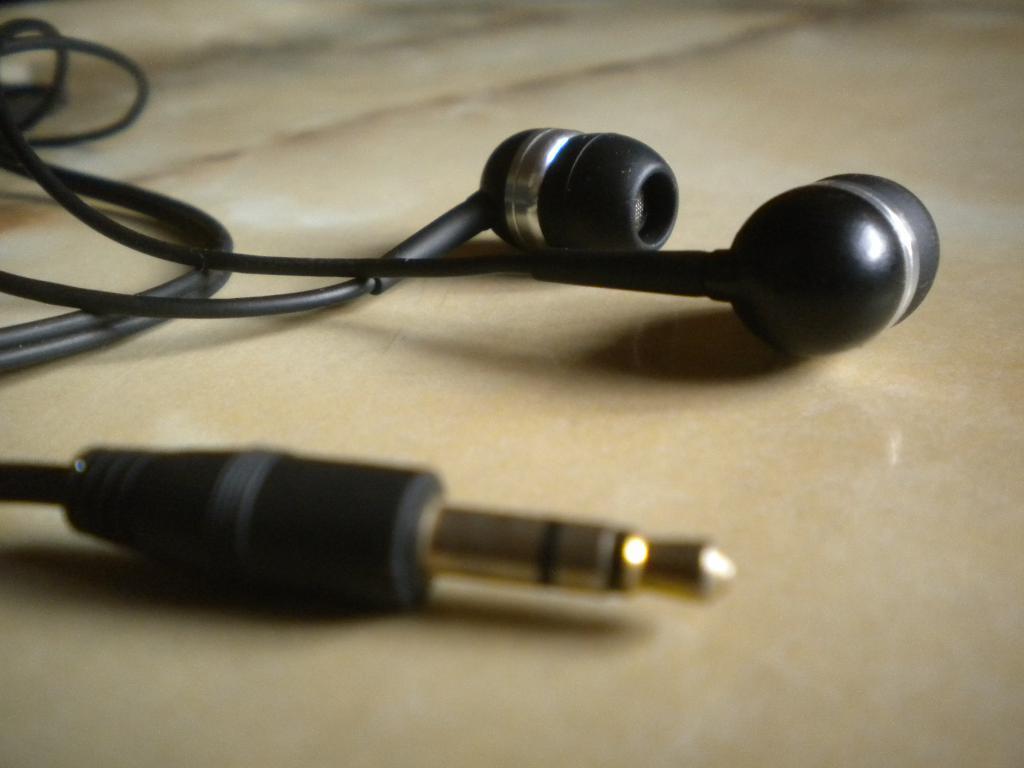Describe this image in one or two sentences. In this picture we can see wired earphones in the front, at the bottom it looks like floor. 